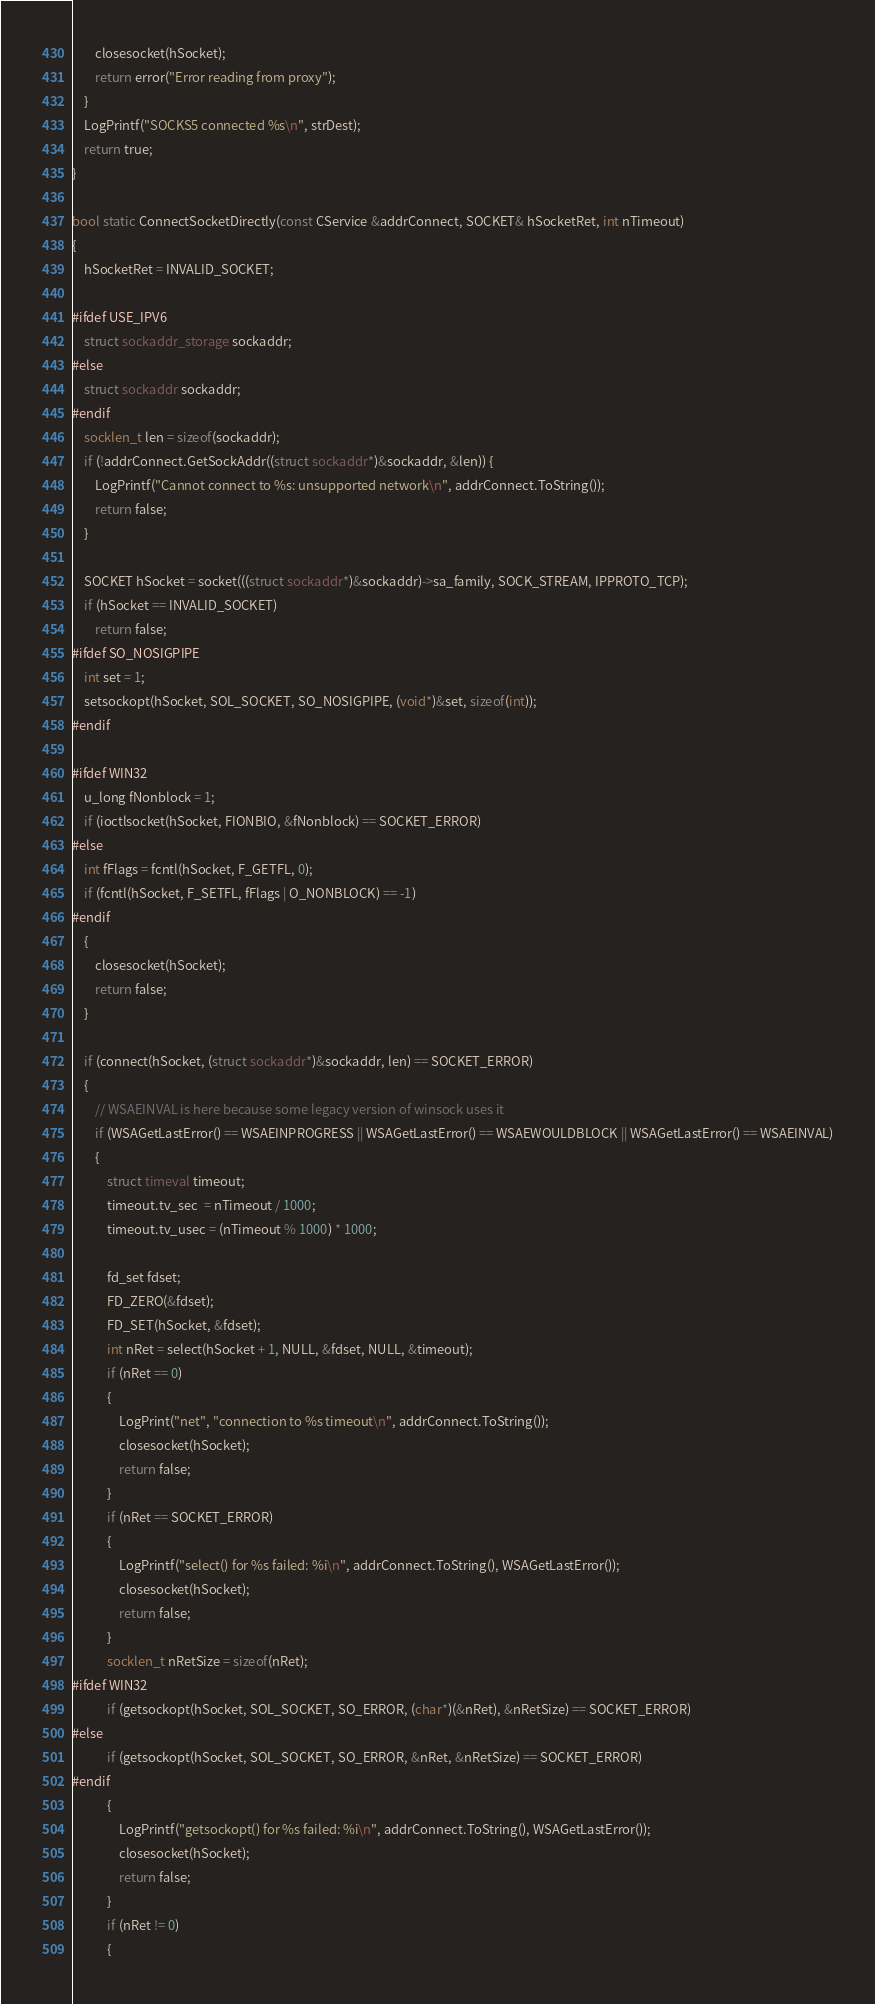<code> <loc_0><loc_0><loc_500><loc_500><_C++_>        closesocket(hSocket);
        return error("Error reading from proxy");
    }
    LogPrintf("SOCKS5 connected %s\n", strDest);
    return true;
}

bool static ConnectSocketDirectly(const CService &addrConnect, SOCKET& hSocketRet, int nTimeout)
{
    hSocketRet = INVALID_SOCKET;

#ifdef USE_IPV6
    struct sockaddr_storage sockaddr;
#else
    struct sockaddr sockaddr;
#endif
    socklen_t len = sizeof(sockaddr);
    if (!addrConnect.GetSockAddr((struct sockaddr*)&sockaddr, &len)) {
        LogPrintf("Cannot connect to %s: unsupported network\n", addrConnect.ToString());
        return false;
    }

    SOCKET hSocket = socket(((struct sockaddr*)&sockaddr)->sa_family, SOCK_STREAM, IPPROTO_TCP);
    if (hSocket == INVALID_SOCKET)
        return false;
#ifdef SO_NOSIGPIPE
    int set = 1;
    setsockopt(hSocket, SOL_SOCKET, SO_NOSIGPIPE, (void*)&set, sizeof(int));
#endif

#ifdef WIN32
    u_long fNonblock = 1;
    if (ioctlsocket(hSocket, FIONBIO, &fNonblock) == SOCKET_ERROR)
#else
    int fFlags = fcntl(hSocket, F_GETFL, 0);
    if (fcntl(hSocket, F_SETFL, fFlags | O_NONBLOCK) == -1)
#endif
    {
        closesocket(hSocket);
        return false;
    }

    if (connect(hSocket, (struct sockaddr*)&sockaddr, len) == SOCKET_ERROR)
    {
        // WSAEINVAL is here because some legacy version of winsock uses it
        if (WSAGetLastError() == WSAEINPROGRESS || WSAGetLastError() == WSAEWOULDBLOCK || WSAGetLastError() == WSAEINVAL)
        {
            struct timeval timeout;
            timeout.tv_sec  = nTimeout / 1000;
            timeout.tv_usec = (nTimeout % 1000) * 1000;

            fd_set fdset;
            FD_ZERO(&fdset);
            FD_SET(hSocket, &fdset);
            int nRet = select(hSocket + 1, NULL, &fdset, NULL, &timeout);
            if (nRet == 0)
            {
                LogPrint("net", "connection to %s timeout\n", addrConnect.ToString());
                closesocket(hSocket);
                return false;
            }
            if (nRet == SOCKET_ERROR)
            {
                LogPrintf("select() for %s failed: %i\n", addrConnect.ToString(), WSAGetLastError());
                closesocket(hSocket);
                return false;
            }
            socklen_t nRetSize = sizeof(nRet);
#ifdef WIN32
            if (getsockopt(hSocket, SOL_SOCKET, SO_ERROR, (char*)(&nRet), &nRetSize) == SOCKET_ERROR)
#else
            if (getsockopt(hSocket, SOL_SOCKET, SO_ERROR, &nRet, &nRetSize) == SOCKET_ERROR)
#endif
            {
                LogPrintf("getsockopt() for %s failed: %i\n", addrConnect.ToString(), WSAGetLastError());
                closesocket(hSocket);
                return false;
            }
            if (nRet != 0)
            {</code> 